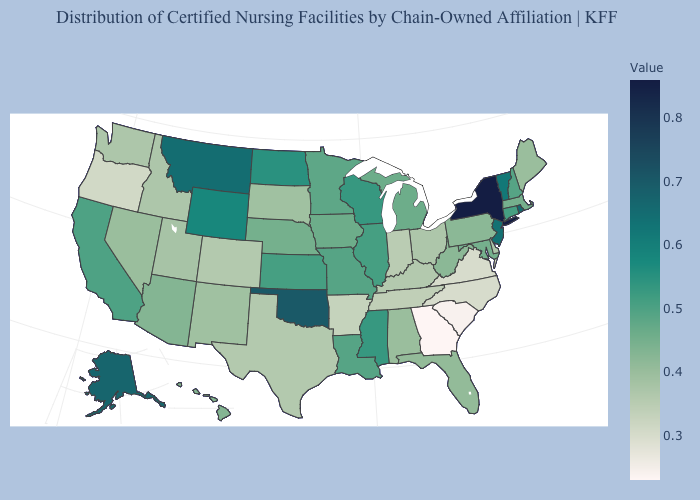Does Utah have a higher value than Virginia?
Concise answer only. Yes. Is the legend a continuous bar?
Concise answer only. Yes. Among the states that border Maryland , does Delaware have the highest value?
Short answer required. No. Is the legend a continuous bar?
Quick response, please. Yes. Which states hav the highest value in the Northeast?
Short answer required. New York. Does the map have missing data?
Concise answer only. No. Among the states that border Kansas , does Colorado have the lowest value?
Concise answer only. Yes. 